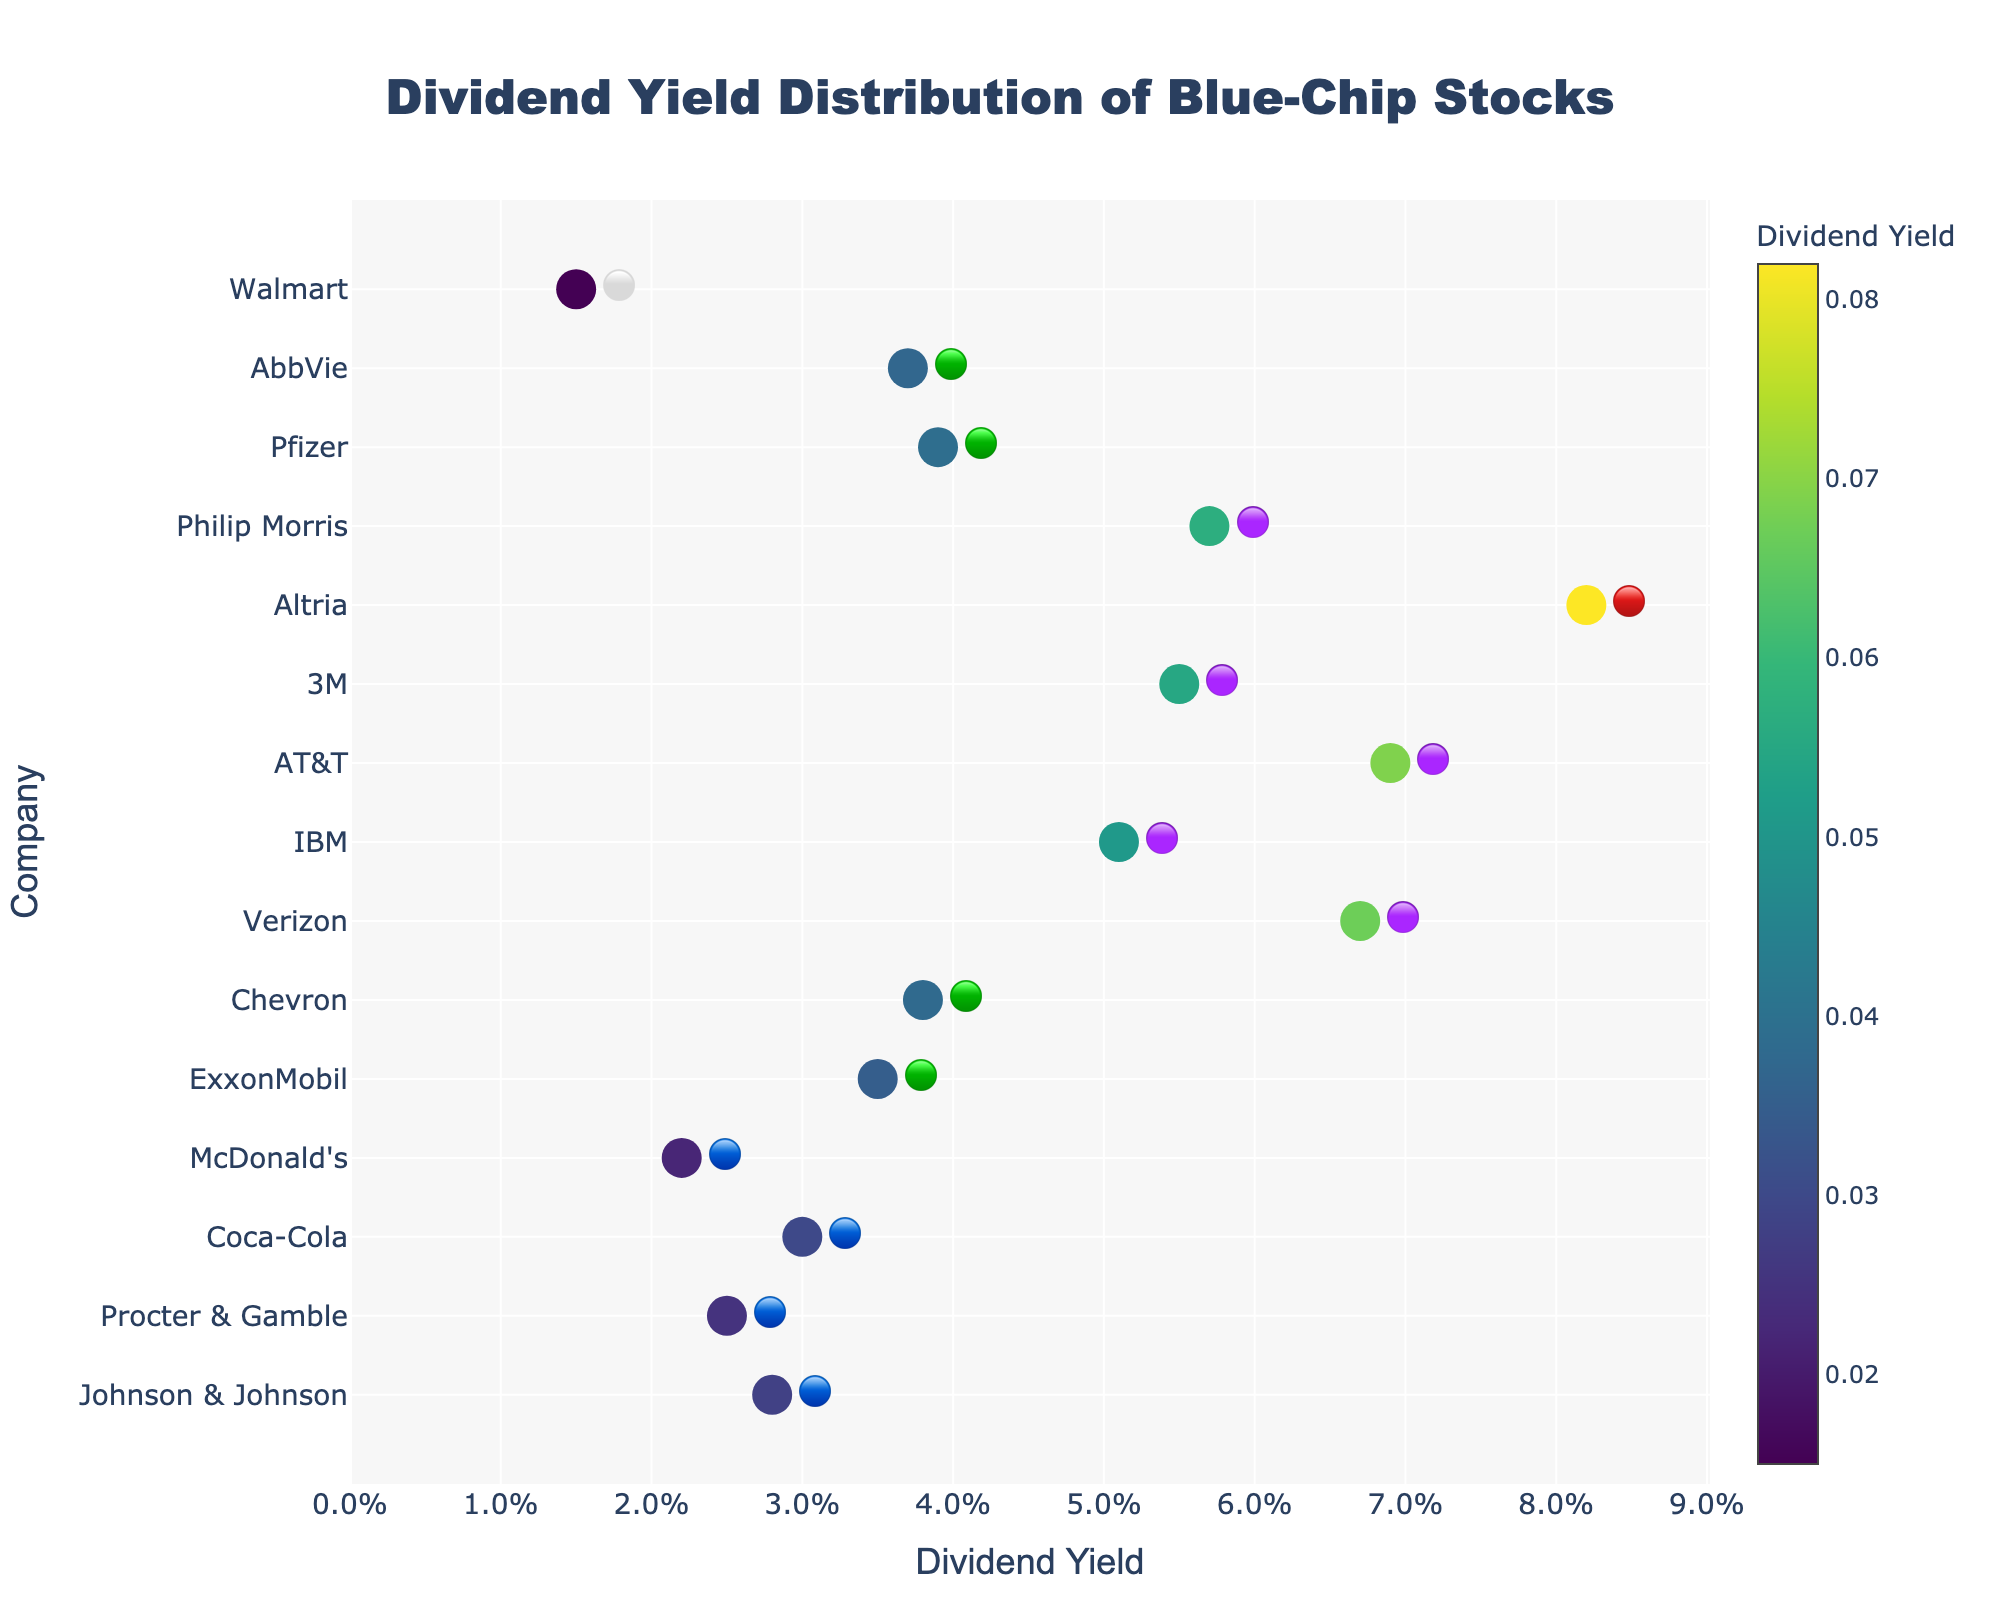Which company has the highest dividend yield? From the chart, locate the company with the highest position on the Dividend Yield axis, indicated by the emoji next to the company name.
Answer: Altria (MO) Which company has the lowest dividend yield? From the chart, locate the company with the lowest position on the Dividend Yield axis, indicated by the emoji next to the company name.
Answer: Walmart (WMT) How many companies are in the 🟢 (green) emoji tier? Count the number of companies that have a green emoji tier next to their names.
Answer: 4 What is the average dividend yield of the companies in the 🔵 (blue) emoji tier? First, identify the companies in the blue emoji tier (Johnson & Johnson, Procter & Gamble, Coca-Cola, McDonald's). Sum their yields (2.8% + 2.5% + 3.0% + 2.2%) and divide by the number of companies (4).
Answer: 2.625% Which company offers a higher dividend yield, ExxonMobil or Pfizer? Compare the Dividend Yields of ExxonMobil (🟢) and Pfizer (🟢) from the chart.
Answer: Pfizer (PFE) What is the difference in dividend yield between the company with the highest yield and the company with the lowest yield? Find the yields for the highest (Altria, 8.2%) and lowest (Walmart, 1.5%) dividend yield companies, then subtract the lowest from the highest (8.2% - 1.5%).
Answer: 6.7% What is the median dividend yield of all the companies in the 🟣 (purple) emoji tier? Identify the companies in the purple emoji tier (Verizon, IBM, AT&T, 3M, Philip Morris), order their yields (6.7%, 5.1%, 6.9%, 5.5%, 5.7%), and find the middle value.
Answer: 5.7% How does the average dividend yield of ⚪ (white) emoji tier compare to 🟢 (green) emoji tier? Calculate the average yield of the white tier (Walmart, 1.5%) and green tier (ExxonMobil, Chevron, Pfizer, AbbVie: 3.5% + 3.8% + 3.9% + 3.7% = 3.725%).
Answer: The green tier has a higher average yield Which company from the 🔴 (red) emoji tier has the highest dividend yield, and what is it? Identify the company in the red emoji tier (Altria) and read its dividend yield.
Answer: Altria (8.2%) Which company has a dividend yield closest to 4%? Find the company whose dividend yield is closest to 4%, which is just below Pfizer (3.9%).
Answer: Pfizer (PFE) 